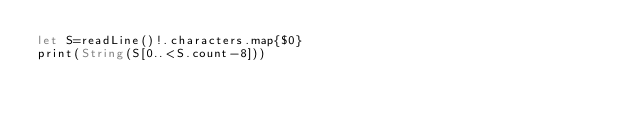Convert code to text. <code><loc_0><loc_0><loc_500><loc_500><_Swift_>let S=readLine()!.characters.map{$0}
print(String(S[0..<S.count-8]))</code> 